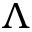Convert formula to latex. <formula><loc_0><loc_0><loc_500><loc_500>\Lambda</formula> 